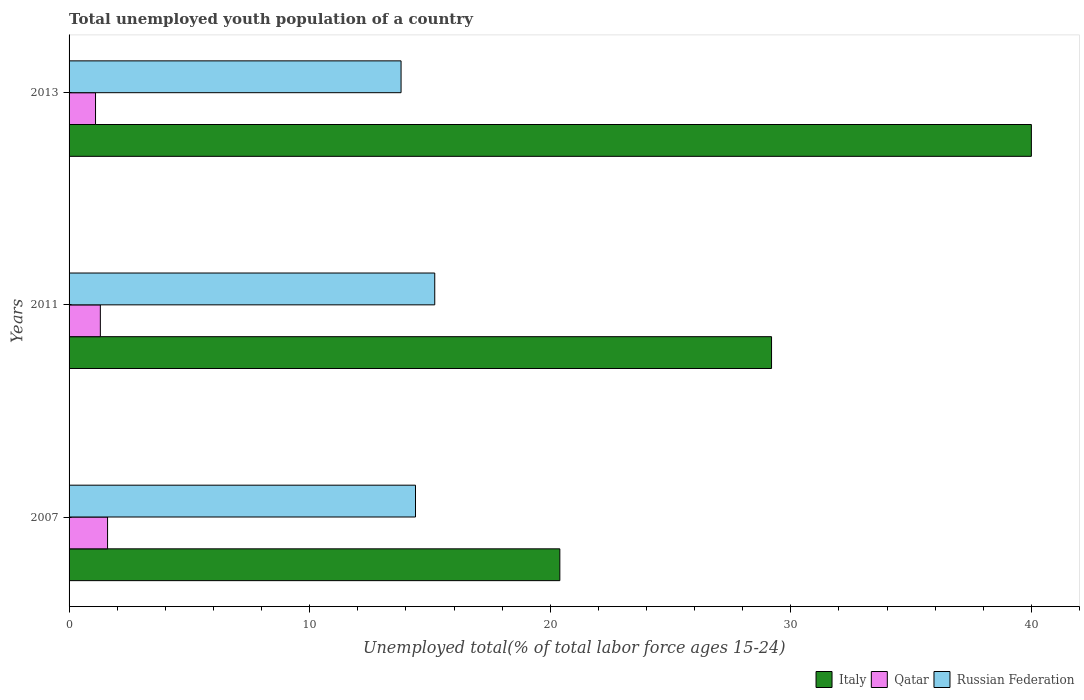How many different coloured bars are there?
Make the answer very short. 3. Are the number of bars per tick equal to the number of legend labels?
Provide a short and direct response. Yes. How many bars are there on the 1st tick from the top?
Keep it short and to the point. 3. How many bars are there on the 3rd tick from the bottom?
Make the answer very short. 3. What is the percentage of total unemployed youth population of a country in Qatar in 2007?
Your answer should be very brief. 1.6. Across all years, what is the maximum percentage of total unemployed youth population of a country in Russian Federation?
Offer a terse response. 15.2. Across all years, what is the minimum percentage of total unemployed youth population of a country in Italy?
Ensure brevity in your answer.  20.4. In which year was the percentage of total unemployed youth population of a country in Russian Federation minimum?
Ensure brevity in your answer.  2013. What is the difference between the percentage of total unemployed youth population of a country in Russian Federation in 2007 and that in 2011?
Provide a succinct answer. -0.8. What is the difference between the percentage of total unemployed youth population of a country in Italy in 2011 and the percentage of total unemployed youth population of a country in Qatar in 2013?
Make the answer very short. 28.1. What is the average percentage of total unemployed youth population of a country in Qatar per year?
Your response must be concise. 1.33. In the year 2007, what is the difference between the percentage of total unemployed youth population of a country in Qatar and percentage of total unemployed youth population of a country in Russian Federation?
Keep it short and to the point. -12.8. What is the ratio of the percentage of total unemployed youth population of a country in Italy in 2007 to that in 2011?
Provide a succinct answer. 0.7. Is the difference between the percentage of total unemployed youth population of a country in Qatar in 2007 and 2011 greater than the difference between the percentage of total unemployed youth population of a country in Russian Federation in 2007 and 2011?
Your answer should be compact. Yes. What is the difference between the highest and the second highest percentage of total unemployed youth population of a country in Qatar?
Offer a very short reply. 0.3. What is the difference between the highest and the lowest percentage of total unemployed youth population of a country in Russian Federation?
Offer a terse response. 1.4. In how many years, is the percentage of total unemployed youth population of a country in Italy greater than the average percentage of total unemployed youth population of a country in Italy taken over all years?
Provide a succinct answer. 1. What does the 2nd bar from the bottom in 2011 represents?
Your response must be concise. Qatar. Is it the case that in every year, the sum of the percentage of total unemployed youth population of a country in Russian Federation and percentage of total unemployed youth population of a country in Italy is greater than the percentage of total unemployed youth population of a country in Qatar?
Make the answer very short. Yes. How many bars are there?
Your answer should be compact. 9. How many years are there in the graph?
Make the answer very short. 3. What is the difference between two consecutive major ticks on the X-axis?
Give a very brief answer. 10. Are the values on the major ticks of X-axis written in scientific E-notation?
Make the answer very short. No. What is the title of the graph?
Give a very brief answer. Total unemployed youth population of a country. Does "Ghana" appear as one of the legend labels in the graph?
Your answer should be very brief. No. What is the label or title of the X-axis?
Provide a succinct answer. Unemployed total(% of total labor force ages 15-24). What is the label or title of the Y-axis?
Provide a short and direct response. Years. What is the Unemployed total(% of total labor force ages 15-24) in Italy in 2007?
Your answer should be very brief. 20.4. What is the Unemployed total(% of total labor force ages 15-24) of Qatar in 2007?
Provide a succinct answer. 1.6. What is the Unemployed total(% of total labor force ages 15-24) of Russian Federation in 2007?
Give a very brief answer. 14.4. What is the Unemployed total(% of total labor force ages 15-24) of Italy in 2011?
Your answer should be very brief. 29.2. What is the Unemployed total(% of total labor force ages 15-24) of Qatar in 2011?
Make the answer very short. 1.3. What is the Unemployed total(% of total labor force ages 15-24) of Russian Federation in 2011?
Offer a terse response. 15.2. What is the Unemployed total(% of total labor force ages 15-24) of Qatar in 2013?
Your answer should be compact. 1.1. What is the Unemployed total(% of total labor force ages 15-24) in Russian Federation in 2013?
Provide a short and direct response. 13.8. Across all years, what is the maximum Unemployed total(% of total labor force ages 15-24) in Italy?
Give a very brief answer. 40. Across all years, what is the maximum Unemployed total(% of total labor force ages 15-24) of Qatar?
Give a very brief answer. 1.6. Across all years, what is the maximum Unemployed total(% of total labor force ages 15-24) of Russian Federation?
Provide a short and direct response. 15.2. Across all years, what is the minimum Unemployed total(% of total labor force ages 15-24) of Italy?
Your response must be concise. 20.4. Across all years, what is the minimum Unemployed total(% of total labor force ages 15-24) of Qatar?
Your answer should be compact. 1.1. Across all years, what is the minimum Unemployed total(% of total labor force ages 15-24) of Russian Federation?
Give a very brief answer. 13.8. What is the total Unemployed total(% of total labor force ages 15-24) in Italy in the graph?
Your answer should be very brief. 89.6. What is the total Unemployed total(% of total labor force ages 15-24) in Russian Federation in the graph?
Offer a very short reply. 43.4. What is the difference between the Unemployed total(% of total labor force ages 15-24) of Qatar in 2007 and that in 2011?
Offer a very short reply. 0.3. What is the difference between the Unemployed total(% of total labor force ages 15-24) of Russian Federation in 2007 and that in 2011?
Make the answer very short. -0.8. What is the difference between the Unemployed total(% of total labor force ages 15-24) in Italy in 2007 and that in 2013?
Provide a short and direct response. -19.6. What is the difference between the Unemployed total(% of total labor force ages 15-24) of Qatar in 2007 and that in 2013?
Provide a succinct answer. 0.5. What is the difference between the Unemployed total(% of total labor force ages 15-24) of Italy in 2011 and that in 2013?
Offer a very short reply. -10.8. What is the difference between the Unemployed total(% of total labor force ages 15-24) in Qatar in 2011 and that in 2013?
Ensure brevity in your answer.  0.2. What is the difference between the Unemployed total(% of total labor force ages 15-24) in Russian Federation in 2011 and that in 2013?
Make the answer very short. 1.4. What is the difference between the Unemployed total(% of total labor force ages 15-24) in Italy in 2007 and the Unemployed total(% of total labor force ages 15-24) in Qatar in 2013?
Offer a terse response. 19.3. What is the difference between the Unemployed total(% of total labor force ages 15-24) of Qatar in 2007 and the Unemployed total(% of total labor force ages 15-24) of Russian Federation in 2013?
Make the answer very short. -12.2. What is the difference between the Unemployed total(% of total labor force ages 15-24) of Italy in 2011 and the Unemployed total(% of total labor force ages 15-24) of Qatar in 2013?
Give a very brief answer. 28.1. What is the difference between the Unemployed total(% of total labor force ages 15-24) in Italy in 2011 and the Unemployed total(% of total labor force ages 15-24) in Russian Federation in 2013?
Your answer should be very brief. 15.4. What is the difference between the Unemployed total(% of total labor force ages 15-24) in Qatar in 2011 and the Unemployed total(% of total labor force ages 15-24) in Russian Federation in 2013?
Ensure brevity in your answer.  -12.5. What is the average Unemployed total(% of total labor force ages 15-24) in Italy per year?
Give a very brief answer. 29.87. What is the average Unemployed total(% of total labor force ages 15-24) of Qatar per year?
Your answer should be compact. 1.33. What is the average Unemployed total(% of total labor force ages 15-24) in Russian Federation per year?
Keep it short and to the point. 14.47. In the year 2007, what is the difference between the Unemployed total(% of total labor force ages 15-24) of Italy and Unemployed total(% of total labor force ages 15-24) of Qatar?
Your response must be concise. 18.8. In the year 2007, what is the difference between the Unemployed total(% of total labor force ages 15-24) of Qatar and Unemployed total(% of total labor force ages 15-24) of Russian Federation?
Offer a terse response. -12.8. In the year 2011, what is the difference between the Unemployed total(% of total labor force ages 15-24) in Italy and Unemployed total(% of total labor force ages 15-24) in Qatar?
Your answer should be very brief. 27.9. In the year 2011, what is the difference between the Unemployed total(% of total labor force ages 15-24) in Italy and Unemployed total(% of total labor force ages 15-24) in Russian Federation?
Offer a very short reply. 14. In the year 2011, what is the difference between the Unemployed total(% of total labor force ages 15-24) in Qatar and Unemployed total(% of total labor force ages 15-24) in Russian Federation?
Ensure brevity in your answer.  -13.9. In the year 2013, what is the difference between the Unemployed total(% of total labor force ages 15-24) of Italy and Unemployed total(% of total labor force ages 15-24) of Qatar?
Keep it short and to the point. 38.9. In the year 2013, what is the difference between the Unemployed total(% of total labor force ages 15-24) in Italy and Unemployed total(% of total labor force ages 15-24) in Russian Federation?
Keep it short and to the point. 26.2. In the year 2013, what is the difference between the Unemployed total(% of total labor force ages 15-24) in Qatar and Unemployed total(% of total labor force ages 15-24) in Russian Federation?
Your answer should be compact. -12.7. What is the ratio of the Unemployed total(% of total labor force ages 15-24) in Italy in 2007 to that in 2011?
Give a very brief answer. 0.7. What is the ratio of the Unemployed total(% of total labor force ages 15-24) in Qatar in 2007 to that in 2011?
Offer a very short reply. 1.23. What is the ratio of the Unemployed total(% of total labor force ages 15-24) in Italy in 2007 to that in 2013?
Provide a succinct answer. 0.51. What is the ratio of the Unemployed total(% of total labor force ages 15-24) of Qatar in 2007 to that in 2013?
Make the answer very short. 1.45. What is the ratio of the Unemployed total(% of total labor force ages 15-24) in Russian Federation in 2007 to that in 2013?
Your response must be concise. 1.04. What is the ratio of the Unemployed total(% of total labor force ages 15-24) of Italy in 2011 to that in 2013?
Your answer should be compact. 0.73. What is the ratio of the Unemployed total(% of total labor force ages 15-24) of Qatar in 2011 to that in 2013?
Your answer should be compact. 1.18. What is the ratio of the Unemployed total(% of total labor force ages 15-24) in Russian Federation in 2011 to that in 2013?
Make the answer very short. 1.1. What is the difference between the highest and the second highest Unemployed total(% of total labor force ages 15-24) of Italy?
Provide a short and direct response. 10.8. What is the difference between the highest and the second highest Unemployed total(% of total labor force ages 15-24) of Qatar?
Make the answer very short. 0.3. What is the difference between the highest and the second highest Unemployed total(% of total labor force ages 15-24) of Russian Federation?
Offer a very short reply. 0.8. What is the difference between the highest and the lowest Unemployed total(% of total labor force ages 15-24) in Italy?
Give a very brief answer. 19.6. What is the difference between the highest and the lowest Unemployed total(% of total labor force ages 15-24) in Russian Federation?
Make the answer very short. 1.4. 